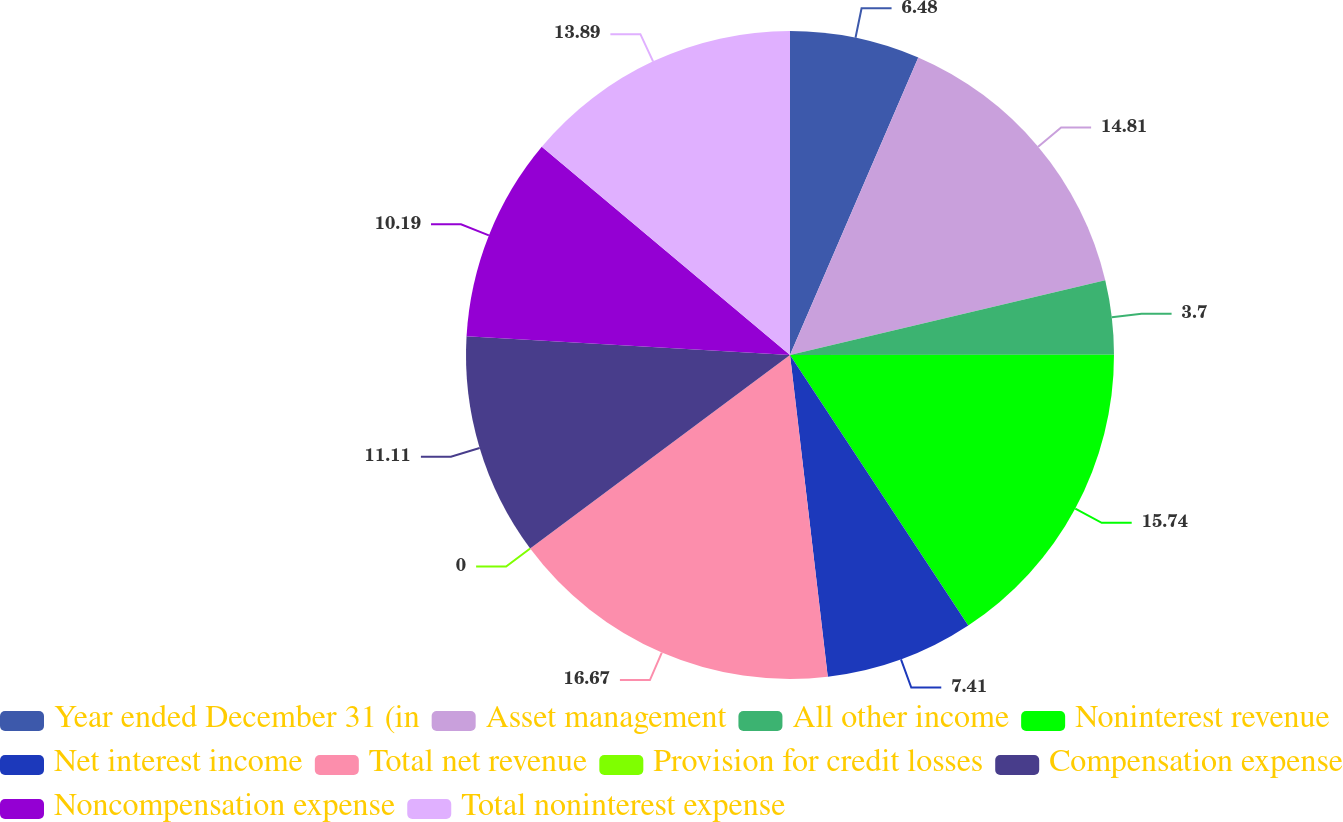Convert chart. <chart><loc_0><loc_0><loc_500><loc_500><pie_chart><fcel>Year ended December 31 (in<fcel>Asset management<fcel>All other income<fcel>Noninterest revenue<fcel>Net interest income<fcel>Total net revenue<fcel>Provision for credit losses<fcel>Compensation expense<fcel>Noncompensation expense<fcel>Total noninterest expense<nl><fcel>6.48%<fcel>14.81%<fcel>3.7%<fcel>15.74%<fcel>7.41%<fcel>16.67%<fcel>0.0%<fcel>11.11%<fcel>10.19%<fcel>13.89%<nl></chart> 